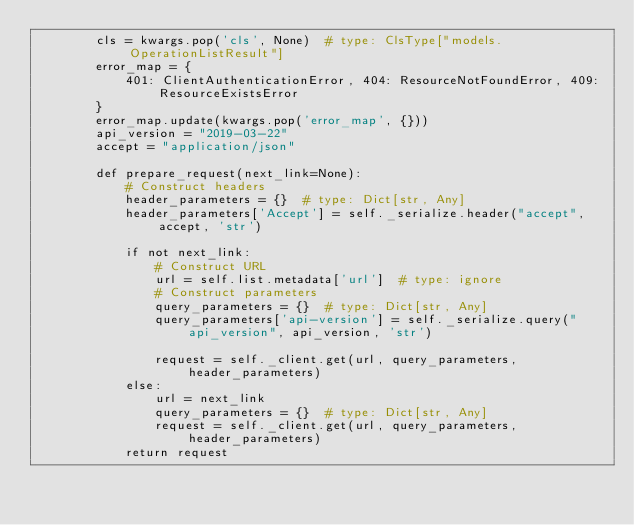Convert code to text. <code><loc_0><loc_0><loc_500><loc_500><_Python_>        cls = kwargs.pop('cls', None)  # type: ClsType["models.OperationListResult"]
        error_map = {
            401: ClientAuthenticationError, 404: ResourceNotFoundError, 409: ResourceExistsError
        }
        error_map.update(kwargs.pop('error_map', {}))
        api_version = "2019-03-22"
        accept = "application/json"

        def prepare_request(next_link=None):
            # Construct headers
            header_parameters = {}  # type: Dict[str, Any]
            header_parameters['Accept'] = self._serialize.header("accept", accept, 'str')

            if not next_link:
                # Construct URL
                url = self.list.metadata['url']  # type: ignore
                # Construct parameters
                query_parameters = {}  # type: Dict[str, Any]
                query_parameters['api-version'] = self._serialize.query("api_version", api_version, 'str')

                request = self._client.get(url, query_parameters, header_parameters)
            else:
                url = next_link
                query_parameters = {}  # type: Dict[str, Any]
                request = self._client.get(url, query_parameters, header_parameters)
            return request
</code> 